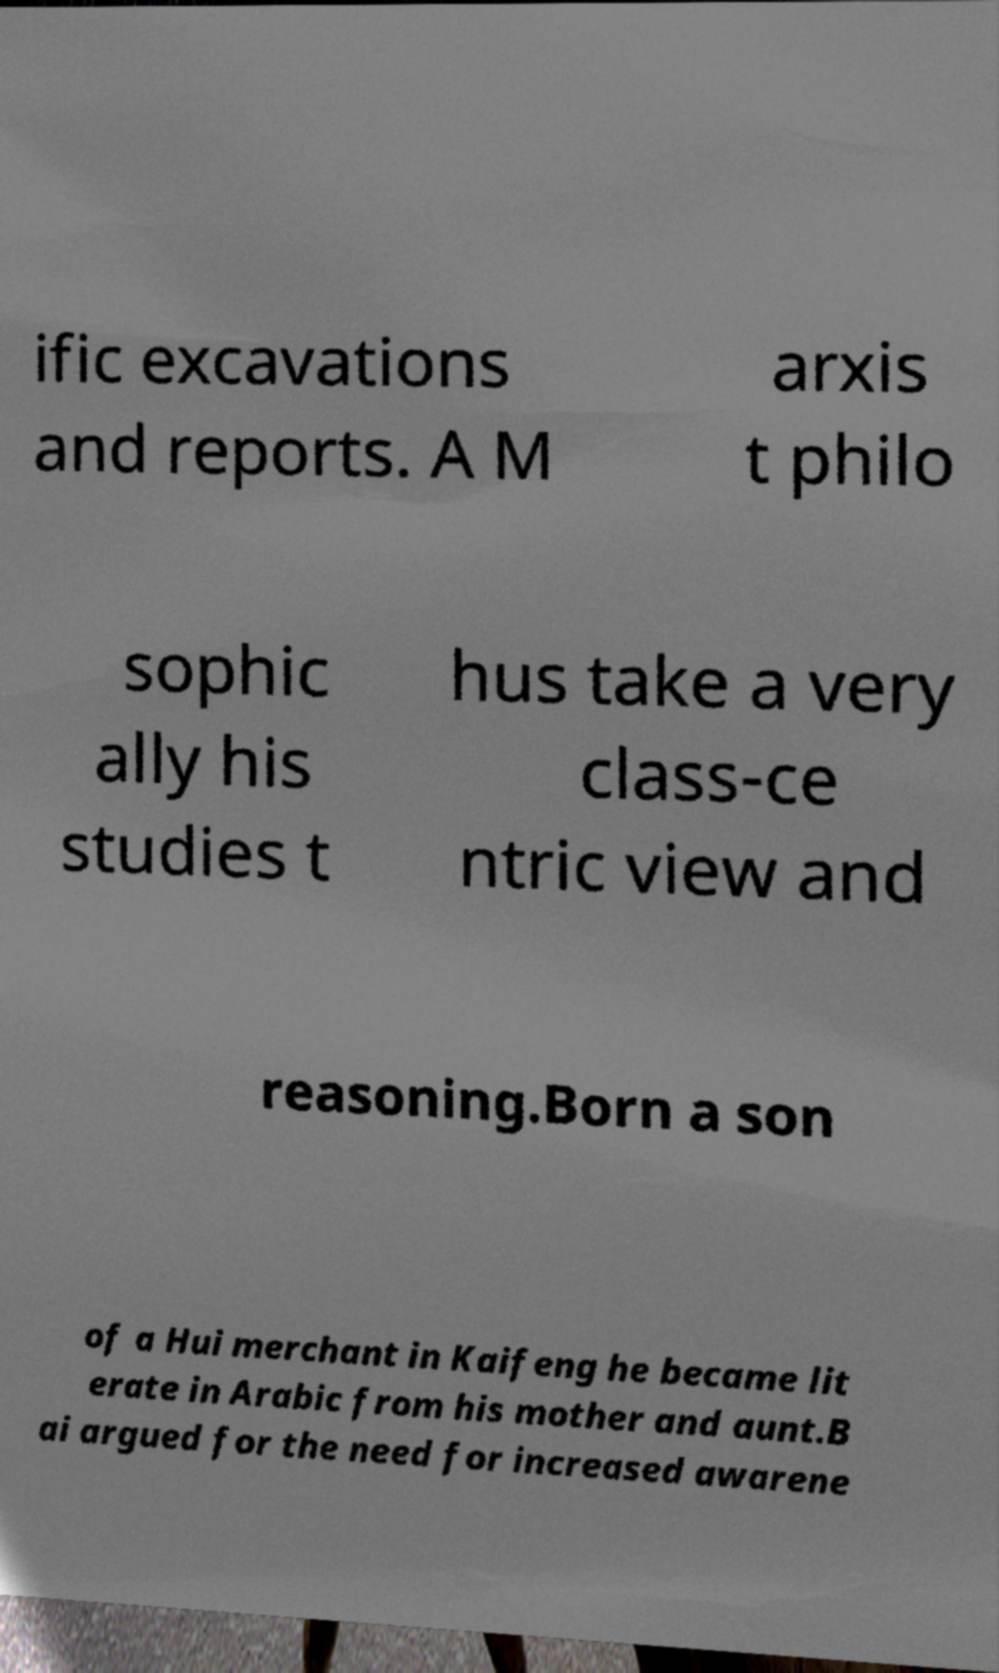Please identify and transcribe the text found in this image. ific excavations and reports. A M arxis t philo sophic ally his studies t hus take a very class-ce ntric view and reasoning.Born a son of a Hui merchant in Kaifeng he became lit erate in Arabic from his mother and aunt.B ai argued for the need for increased awarene 